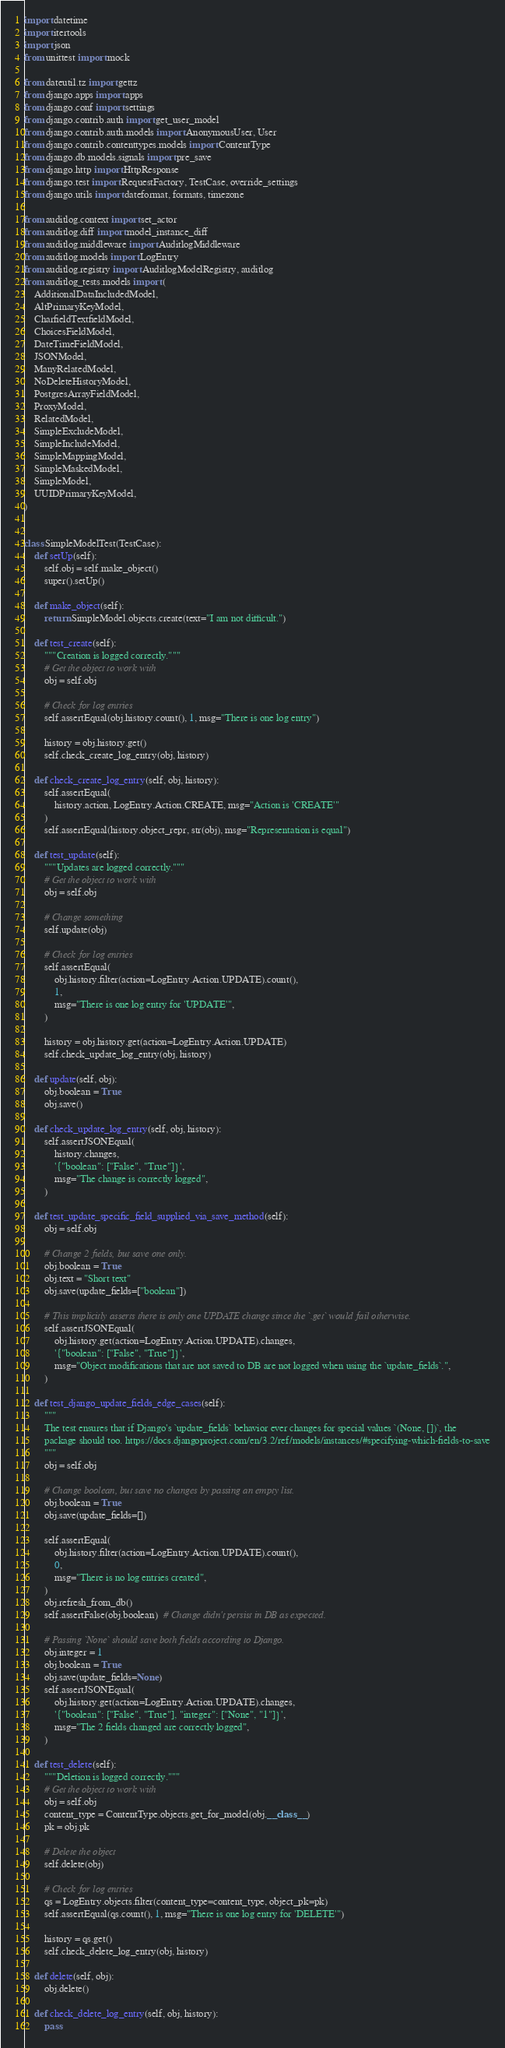<code> <loc_0><loc_0><loc_500><loc_500><_Python_>import datetime
import itertools
import json
from unittest import mock

from dateutil.tz import gettz
from django.apps import apps
from django.conf import settings
from django.contrib.auth import get_user_model
from django.contrib.auth.models import AnonymousUser, User
from django.contrib.contenttypes.models import ContentType
from django.db.models.signals import pre_save
from django.http import HttpResponse
from django.test import RequestFactory, TestCase, override_settings
from django.utils import dateformat, formats, timezone

from auditlog.context import set_actor
from auditlog.diff import model_instance_diff
from auditlog.middleware import AuditlogMiddleware
from auditlog.models import LogEntry
from auditlog.registry import AuditlogModelRegistry, auditlog
from auditlog_tests.models import (
    AdditionalDataIncludedModel,
    AltPrimaryKeyModel,
    CharfieldTextfieldModel,
    ChoicesFieldModel,
    DateTimeFieldModel,
    JSONModel,
    ManyRelatedModel,
    NoDeleteHistoryModel,
    PostgresArrayFieldModel,
    ProxyModel,
    RelatedModel,
    SimpleExcludeModel,
    SimpleIncludeModel,
    SimpleMappingModel,
    SimpleMaskedModel,
    SimpleModel,
    UUIDPrimaryKeyModel,
)


class SimpleModelTest(TestCase):
    def setUp(self):
        self.obj = self.make_object()
        super().setUp()

    def make_object(self):
        return SimpleModel.objects.create(text="I am not difficult.")

    def test_create(self):
        """Creation is logged correctly."""
        # Get the object to work with
        obj = self.obj

        # Check for log entries
        self.assertEqual(obj.history.count(), 1, msg="There is one log entry")

        history = obj.history.get()
        self.check_create_log_entry(obj, history)

    def check_create_log_entry(self, obj, history):
        self.assertEqual(
            history.action, LogEntry.Action.CREATE, msg="Action is 'CREATE'"
        )
        self.assertEqual(history.object_repr, str(obj), msg="Representation is equal")

    def test_update(self):
        """Updates are logged correctly."""
        # Get the object to work with
        obj = self.obj

        # Change something
        self.update(obj)

        # Check for log entries
        self.assertEqual(
            obj.history.filter(action=LogEntry.Action.UPDATE).count(),
            1,
            msg="There is one log entry for 'UPDATE'",
        )

        history = obj.history.get(action=LogEntry.Action.UPDATE)
        self.check_update_log_entry(obj, history)

    def update(self, obj):
        obj.boolean = True
        obj.save()

    def check_update_log_entry(self, obj, history):
        self.assertJSONEqual(
            history.changes,
            '{"boolean": ["False", "True"]}',
            msg="The change is correctly logged",
        )

    def test_update_specific_field_supplied_via_save_method(self):
        obj = self.obj

        # Change 2 fields, but save one only.
        obj.boolean = True
        obj.text = "Short text"
        obj.save(update_fields=["boolean"])

        # This implicitly asserts there is only one UPDATE change since the `.get` would fail otherwise.
        self.assertJSONEqual(
            obj.history.get(action=LogEntry.Action.UPDATE).changes,
            '{"boolean": ["False", "True"]}',
            msg="Object modifications that are not saved to DB are not logged when using the `update_fields`.",
        )

    def test_django_update_fields_edge_cases(self):
        """
        The test ensures that if Django's `update_fields` behavior ever changes for special values `(None, [])`, the
        package should too. https://docs.djangoproject.com/en/3.2/ref/models/instances/#specifying-which-fields-to-save
        """
        obj = self.obj

        # Change boolean, but save no changes by passing an empty list.
        obj.boolean = True
        obj.save(update_fields=[])

        self.assertEqual(
            obj.history.filter(action=LogEntry.Action.UPDATE).count(),
            0,
            msg="There is no log entries created",
        )
        obj.refresh_from_db()
        self.assertFalse(obj.boolean)  # Change didn't persist in DB as expected.

        # Passing `None` should save both fields according to Django.
        obj.integer = 1
        obj.boolean = True
        obj.save(update_fields=None)
        self.assertJSONEqual(
            obj.history.get(action=LogEntry.Action.UPDATE).changes,
            '{"boolean": ["False", "True"], "integer": ["None", "1"]}',
            msg="The 2 fields changed are correctly logged",
        )

    def test_delete(self):
        """Deletion is logged correctly."""
        # Get the object to work with
        obj = self.obj
        content_type = ContentType.objects.get_for_model(obj.__class__)
        pk = obj.pk

        # Delete the object
        self.delete(obj)

        # Check for log entries
        qs = LogEntry.objects.filter(content_type=content_type, object_pk=pk)
        self.assertEqual(qs.count(), 1, msg="There is one log entry for 'DELETE'")

        history = qs.get()
        self.check_delete_log_entry(obj, history)

    def delete(self, obj):
        obj.delete()

    def check_delete_log_entry(self, obj, history):
        pass
</code> 